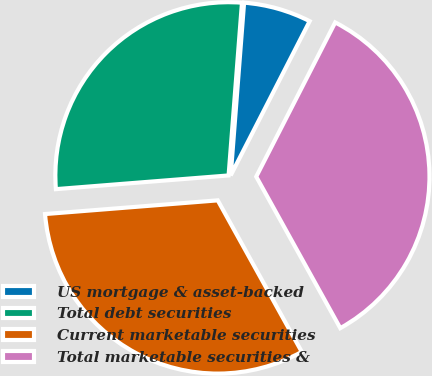<chart> <loc_0><loc_0><loc_500><loc_500><pie_chart><fcel>US mortgage & asset-backed<fcel>Total debt securities<fcel>Current marketable securities<fcel>Total marketable securities &<nl><fcel>6.3%<fcel>27.49%<fcel>31.8%<fcel>34.41%<nl></chart> 